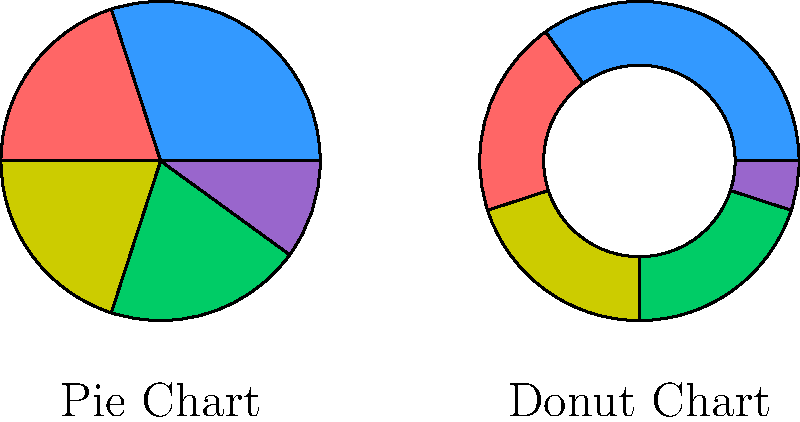Compare the market share distribution of car manufacturers represented by the pie chart and donut chart. Which manufacturer has gained market share in the donut chart compared to the pie chart, and by approximately how many percentage points? To solve this problem, we need to compare the two charts step-by-step:

1. Identify the corresponding segments in both charts:
   - Blue: Largest segment in both charts
   - Red: Second largest in pie chart, third largest in donut chart
   - Yellow: Third largest in pie chart, second largest in donut chart
   - Green: Fourth largest in both charts
   - Purple: Smallest segment in both charts

2. Estimate the angles for each segment in both charts:
   Pie chart:
   - Blue: ~108° (30%)
   - Red: ~72° (20%)
   - Yellow: ~72° (20%)
   - Green: ~72° (20%)
   - Purple: ~36° (10%)

   Donut chart:
   - Blue: ~126° (35%)
   - Yellow: ~72° (20%)
   - Red: ~72° (20%)
   - Green: ~72° (20%)
   - Purple: ~18° (5%)

3. Compare the segments between the two charts:
   - Blue increased from ~30% to ~35% (+5 percentage points)
   - Red remained at ~20% (no change)
   - Yellow remained at ~20% (no change)
   - Green remained at ~20% (no change)
   - Purple decreased from ~10% to ~5% (-5 percentage points)

4. Identify the manufacturer that gained market share:
   The blue segment, representing the largest manufacturer, is the only one that increased its market share.

5. Calculate the increase:
   The blue segment increased by approximately 5 percentage points.
Answer: The largest manufacturer (blue) gained ~5 percentage points. 